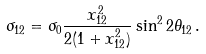Convert formula to latex. <formula><loc_0><loc_0><loc_500><loc_500>\sigma _ { 1 2 } = \sigma _ { 0 } \frac { x _ { 1 2 } ^ { 2 } } { 2 ( 1 + x _ { 1 2 } ^ { 2 } ) } \sin ^ { 2 } 2 \theta _ { 1 2 } \, .</formula> 